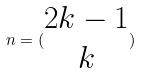<formula> <loc_0><loc_0><loc_500><loc_500>n = ( \begin{matrix} 2 k - 1 \\ k \end{matrix} )</formula> 